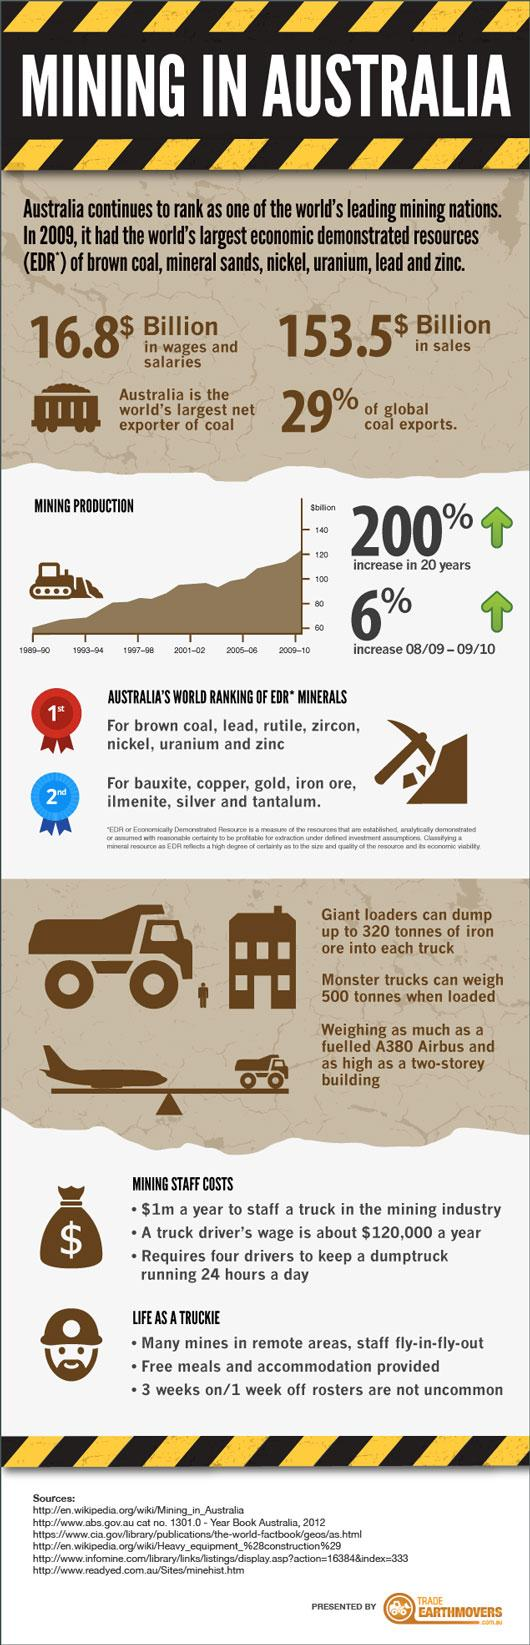Draw attention to some important aspects in this diagram. I'm sorry, but it is not clear what you are asking. Could you provide more context or clarify your question? Six sources are listed at the bottom. 